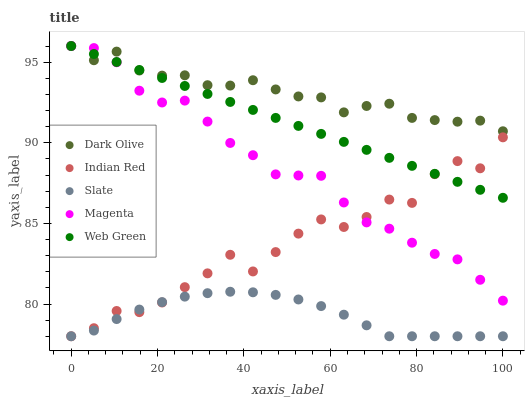Does Slate have the minimum area under the curve?
Answer yes or no. Yes. Does Dark Olive have the maximum area under the curve?
Answer yes or no. Yes. Does Dark Olive have the minimum area under the curve?
Answer yes or no. No. Does Slate have the maximum area under the curve?
Answer yes or no. No. Is Web Green the smoothest?
Answer yes or no. Yes. Is Indian Red the roughest?
Answer yes or no. Yes. Is Slate the smoothest?
Answer yes or no. No. Is Slate the roughest?
Answer yes or no. No. Does Slate have the lowest value?
Answer yes or no. Yes. Does Dark Olive have the lowest value?
Answer yes or no. No. Does Magenta have the highest value?
Answer yes or no. Yes. Does Slate have the highest value?
Answer yes or no. No. Is Slate less than Dark Olive?
Answer yes or no. Yes. Is Dark Olive greater than Slate?
Answer yes or no. Yes. Does Indian Red intersect Slate?
Answer yes or no. Yes. Is Indian Red less than Slate?
Answer yes or no. No. Is Indian Red greater than Slate?
Answer yes or no. No. Does Slate intersect Dark Olive?
Answer yes or no. No. 